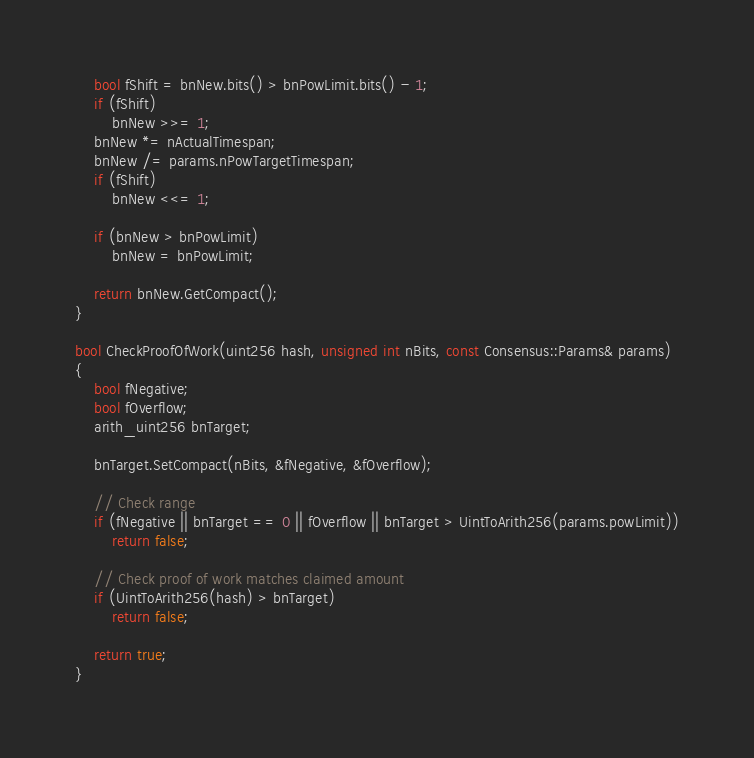<code> <loc_0><loc_0><loc_500><loc_500><_C++_>    bool fShift = bnNew.bits() > bnPowLimit.bits() - 1;
    if (fShift)
        bnNew >>= 1;
    bnNew *= nActualTimespan;
    bnNew /= params.nPowTargetTimespan;
    if (fShift)
        bnNew <<= 1;

    if (bnNew > bnPowLimit)
        bnNew = bnPowLimit;

    return bnNew.GetCompact();
}

bool CheckProofOfWork(uint256 hash, unsigned int nBits, const Consensus::Params& params)
{
    bool fNegative;
    bool fOverflow;
    arith_uint256 bnTarget;

    bnTarget.SetCompact(nBits, &fNegative, &fOverflow);

    // Check range
    if (fNegative || bnTarget == 0 || fOverflow || bnTarget > UintToArith256(params.powLimit))
        return false;

    // Check proof of work matches claimed amount
    if (UintToArith256(hash) > bnTarget)
        return false;

    return true;
}
</code> 